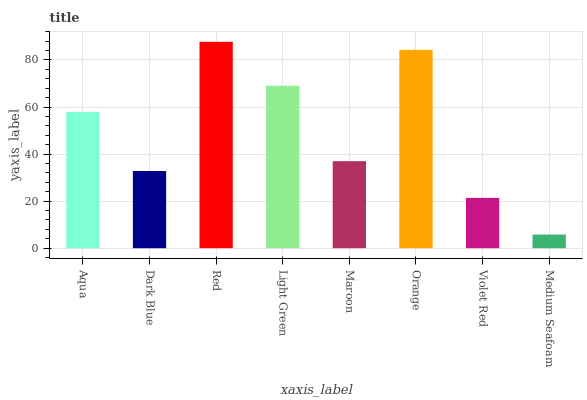Is Medium Seafoam the minimum?
Answer yes or no. Yes. Is Red the maximum?
Answer yes or no. Yes. Is Dark Blue the minimum?
Answer yes or no. No. Is Dark Blue the maximum?
Answer yes or no. No. Is Aqua greater than Dark Blue?
Answer yes or no. Yes. Is Dark Blue less than Aqua?
Answer yes or no. Yes. Is Dark Blue greater than Aqua?
Answer yes or no. No. Is Aqua less than Dark Blue?
Answer yes or no. No. Is Aqua the high median?
Answer yes or no. Yes. Is Maroon the low median?
Answer yes or no. Yes. Is Medium Seafoam the high median?
Answer yes or no. No. Is Red the low median?
Answer yes or no. No. 